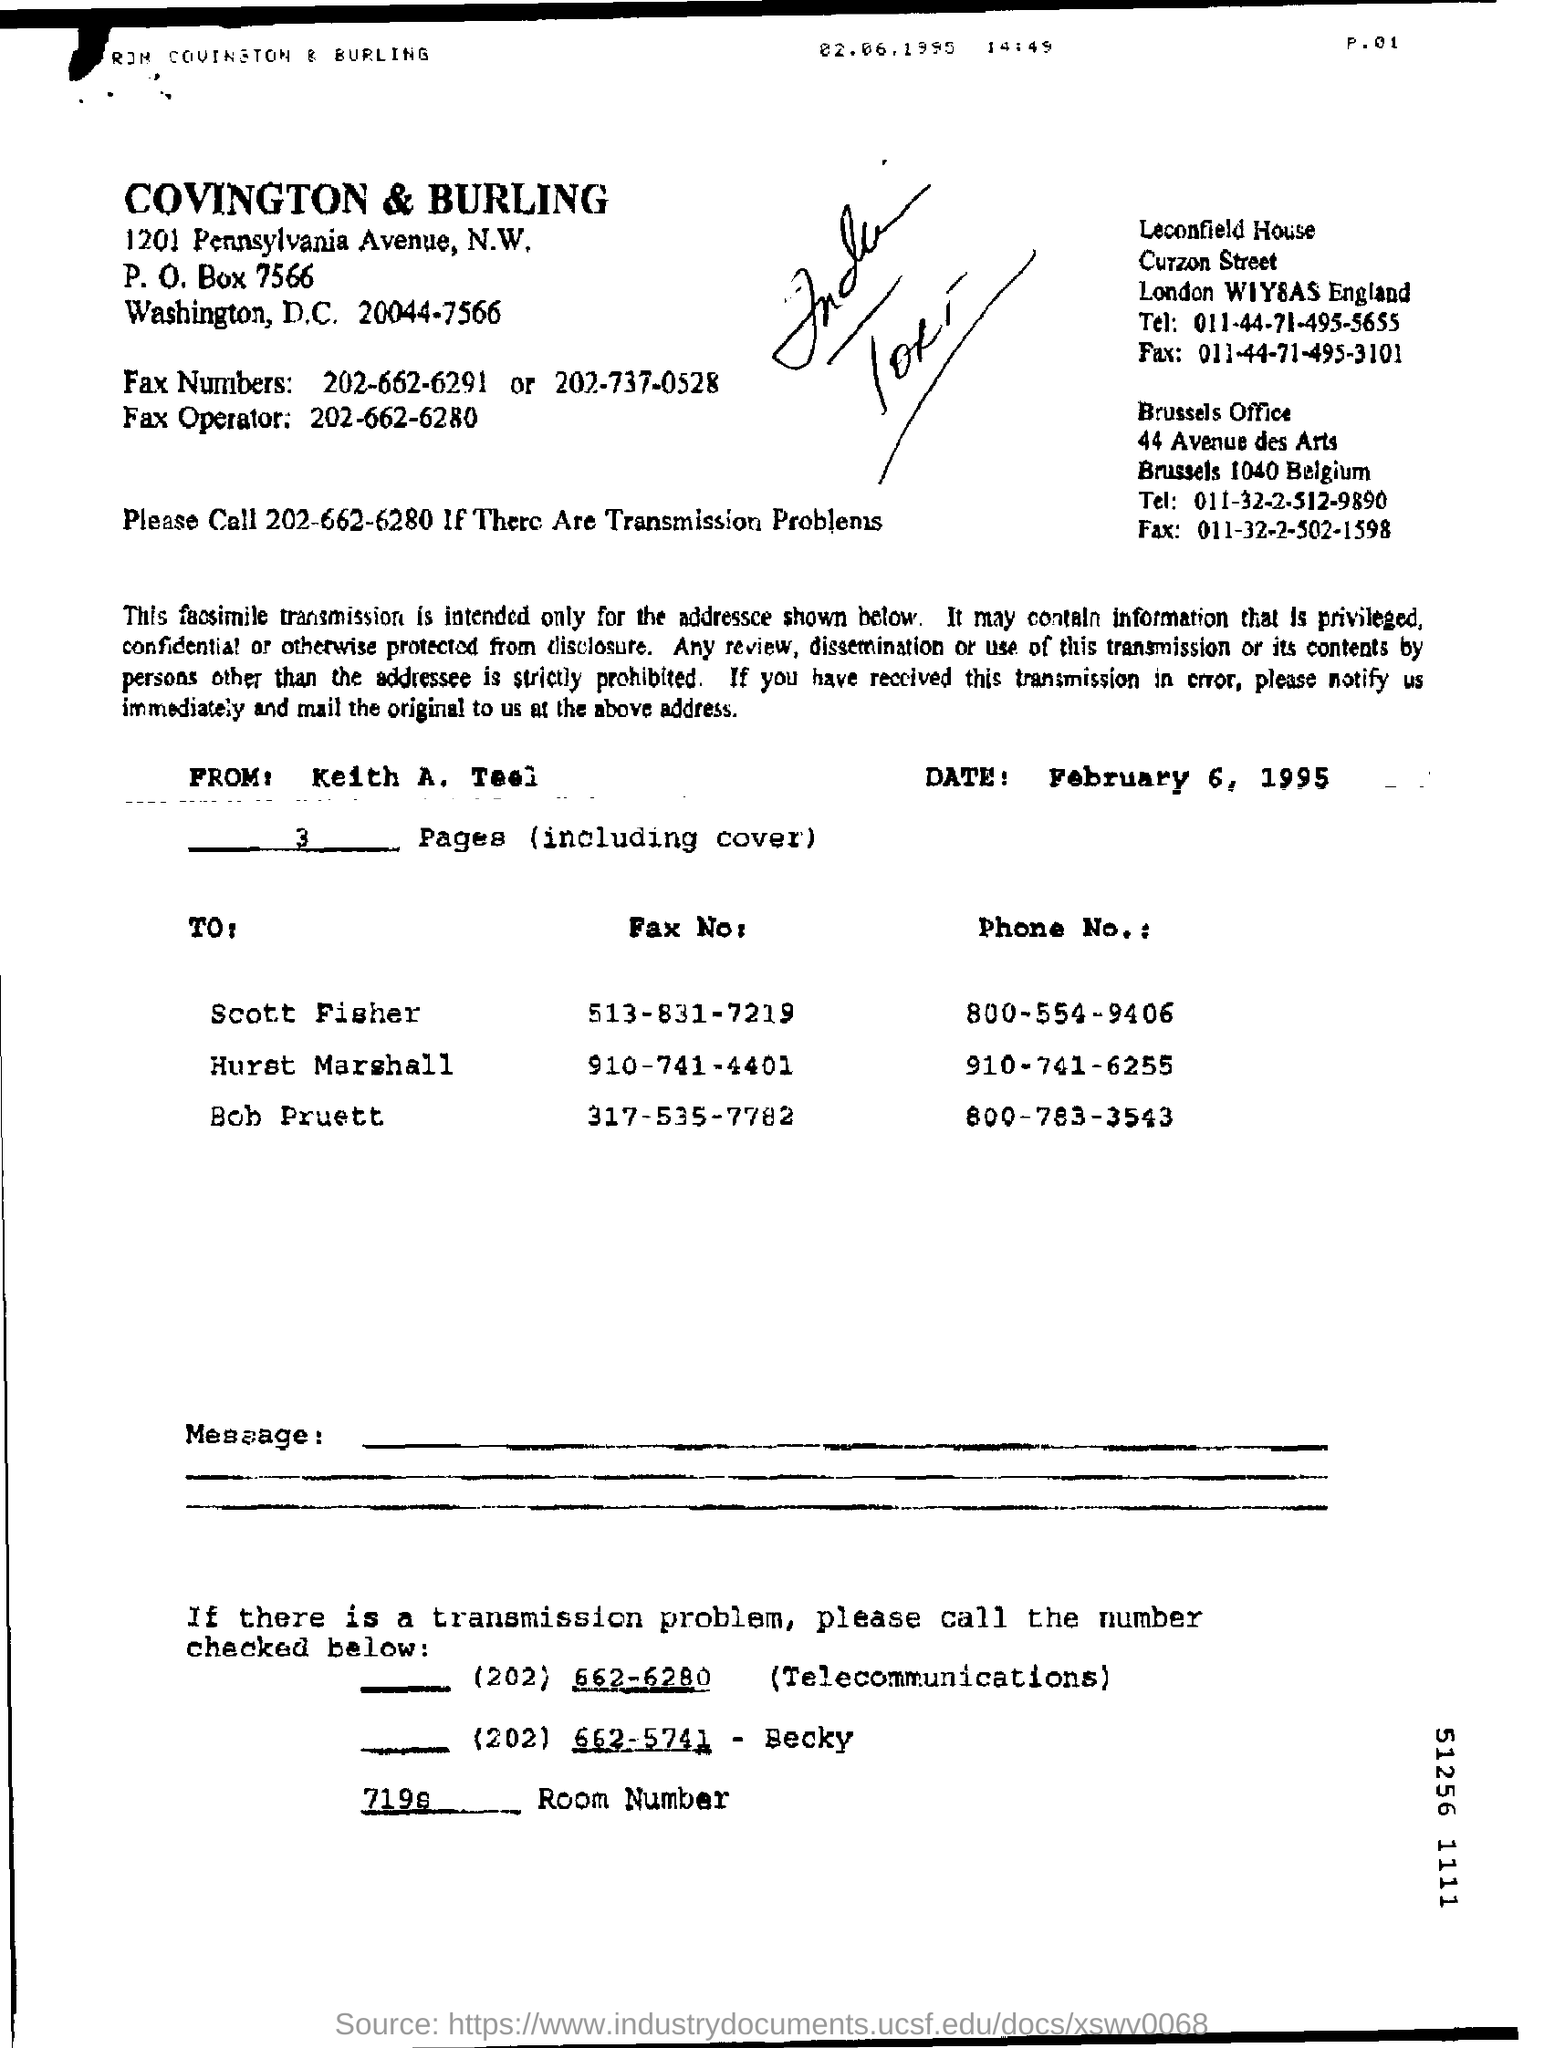Indicate a few pertinent items in this graphic. The phone number for Scott Fisher is 800-554-9406. The letter is from Keith A. Teel. The date on the document is February 6, 1995. The phone number for Bob Pruett is 800-783-3543. 